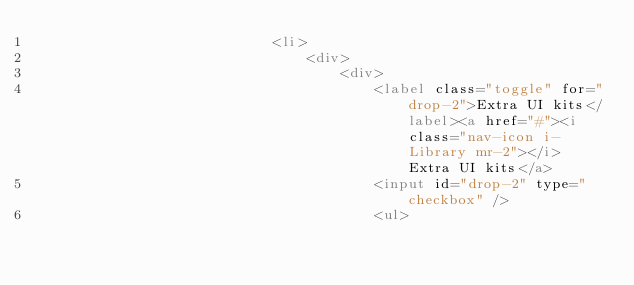Convert code to text. <code><loc_0><loc_0><loc_500><loc_500><_HTML_>                            <li>
                                <div>
                                    <div>
                                        <label class="toggle" for="drop-2">Extra UI kits</label><a href="#"><i class="nav-icon i-Library mr-2"></i> Extra UI kits</a>
                                        <input id="drop-2" type="checkbox" />
                                        <ul></code> 